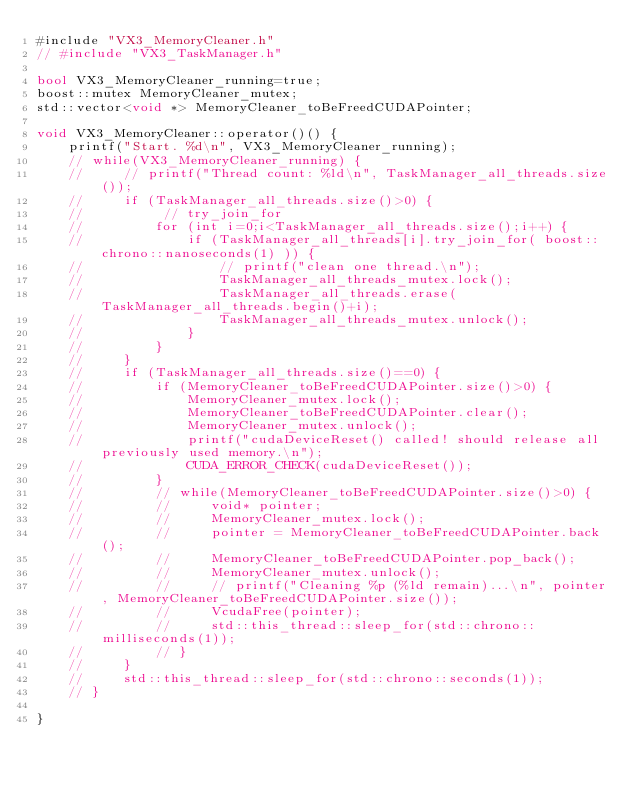<code> <loc_0><loc_0><loc_500><loc_500><_Cuda_>#include "VX3_MemoryCleaner.h"
// #include "VX3_TaskManager.h"

bool VX3_MemoryCleaner_running=true;
boost::mutex MemoryCleaner_mutex;
std::vector<void *> MemoryCleaner_toBeFreedCUDAPointer;

void VX3_MemoryCleaner::operator()() {
    printf("Start. %d\n", VX3_MemoryCleaner_running);
    // while(VX3_MemoryCleaner_running) {
    //     // printf("Thread count: %ld\n", TaskManager_all_threads.size());
    //     if (TaskManager_all_threads.size()>0) {
    //          // try_join_for
    //         for (int i=0;i<TaskManager_all_threads.size();i++) {
    //             if (TaskManager_all_threads[i].try_join_for( boost::chrono::nanoseconds(1) )) {
    //                 // printf("clean one thread.\n");
    //                 TaskManager_all_threads_mutex.lock();
    //                 TaskManager_all_threads.erase(TaskManager_all_threads.begin()+i);
    //                 TaskManager_all_threads_mutex.unlock();
    //             }
    //         }
    //     }
    //     if (TaskManager_all_threads.size()==0) {
    //         if (MemoryCleaner_toBeFreedCUDAPointer.size()>0) {
    //             MemoryCleaner_mutex.lock();
    //             MemoryCleaner_toBeFreedCUDAPointer.clear();
    //             MemoryCleaner_mutex.unlock();
    //             printf("cudaDeviceReset() called! should release all previously used memory.\n");
    //             CUDA_ERROR_CHECK(cudaDeviceReset());
    //         }
    //         // while(MemoryCleaner_toBeFreedCUDAPointer.size()>0) {
    //         //     void* pointer;
    //         //     MemoryCleaner_mutex.lock();
    //         //     pointer = MemoryCleaner_toBeFreedCUDAPointer.back();
    //         //     MemoryCleaner_toBeFreedCUDAPointer.pop_back();
    //         //     MemoryCleaner_mutex.unlock();
    //         //     // printf("Cleaning %p (%ld remain)...\n", pointer, MemoryCleaner_toBeFreedCUDAPointer.size());
    //         //     VcudaFree(pointer);
    //         //     std::this_thread::sleep_for(std::chrono::milliseconds(1));
    //         // }
    //     }
    //     std::this_thread::sleep_for(std::chrono::seconds(1));
    // }

}</code> 